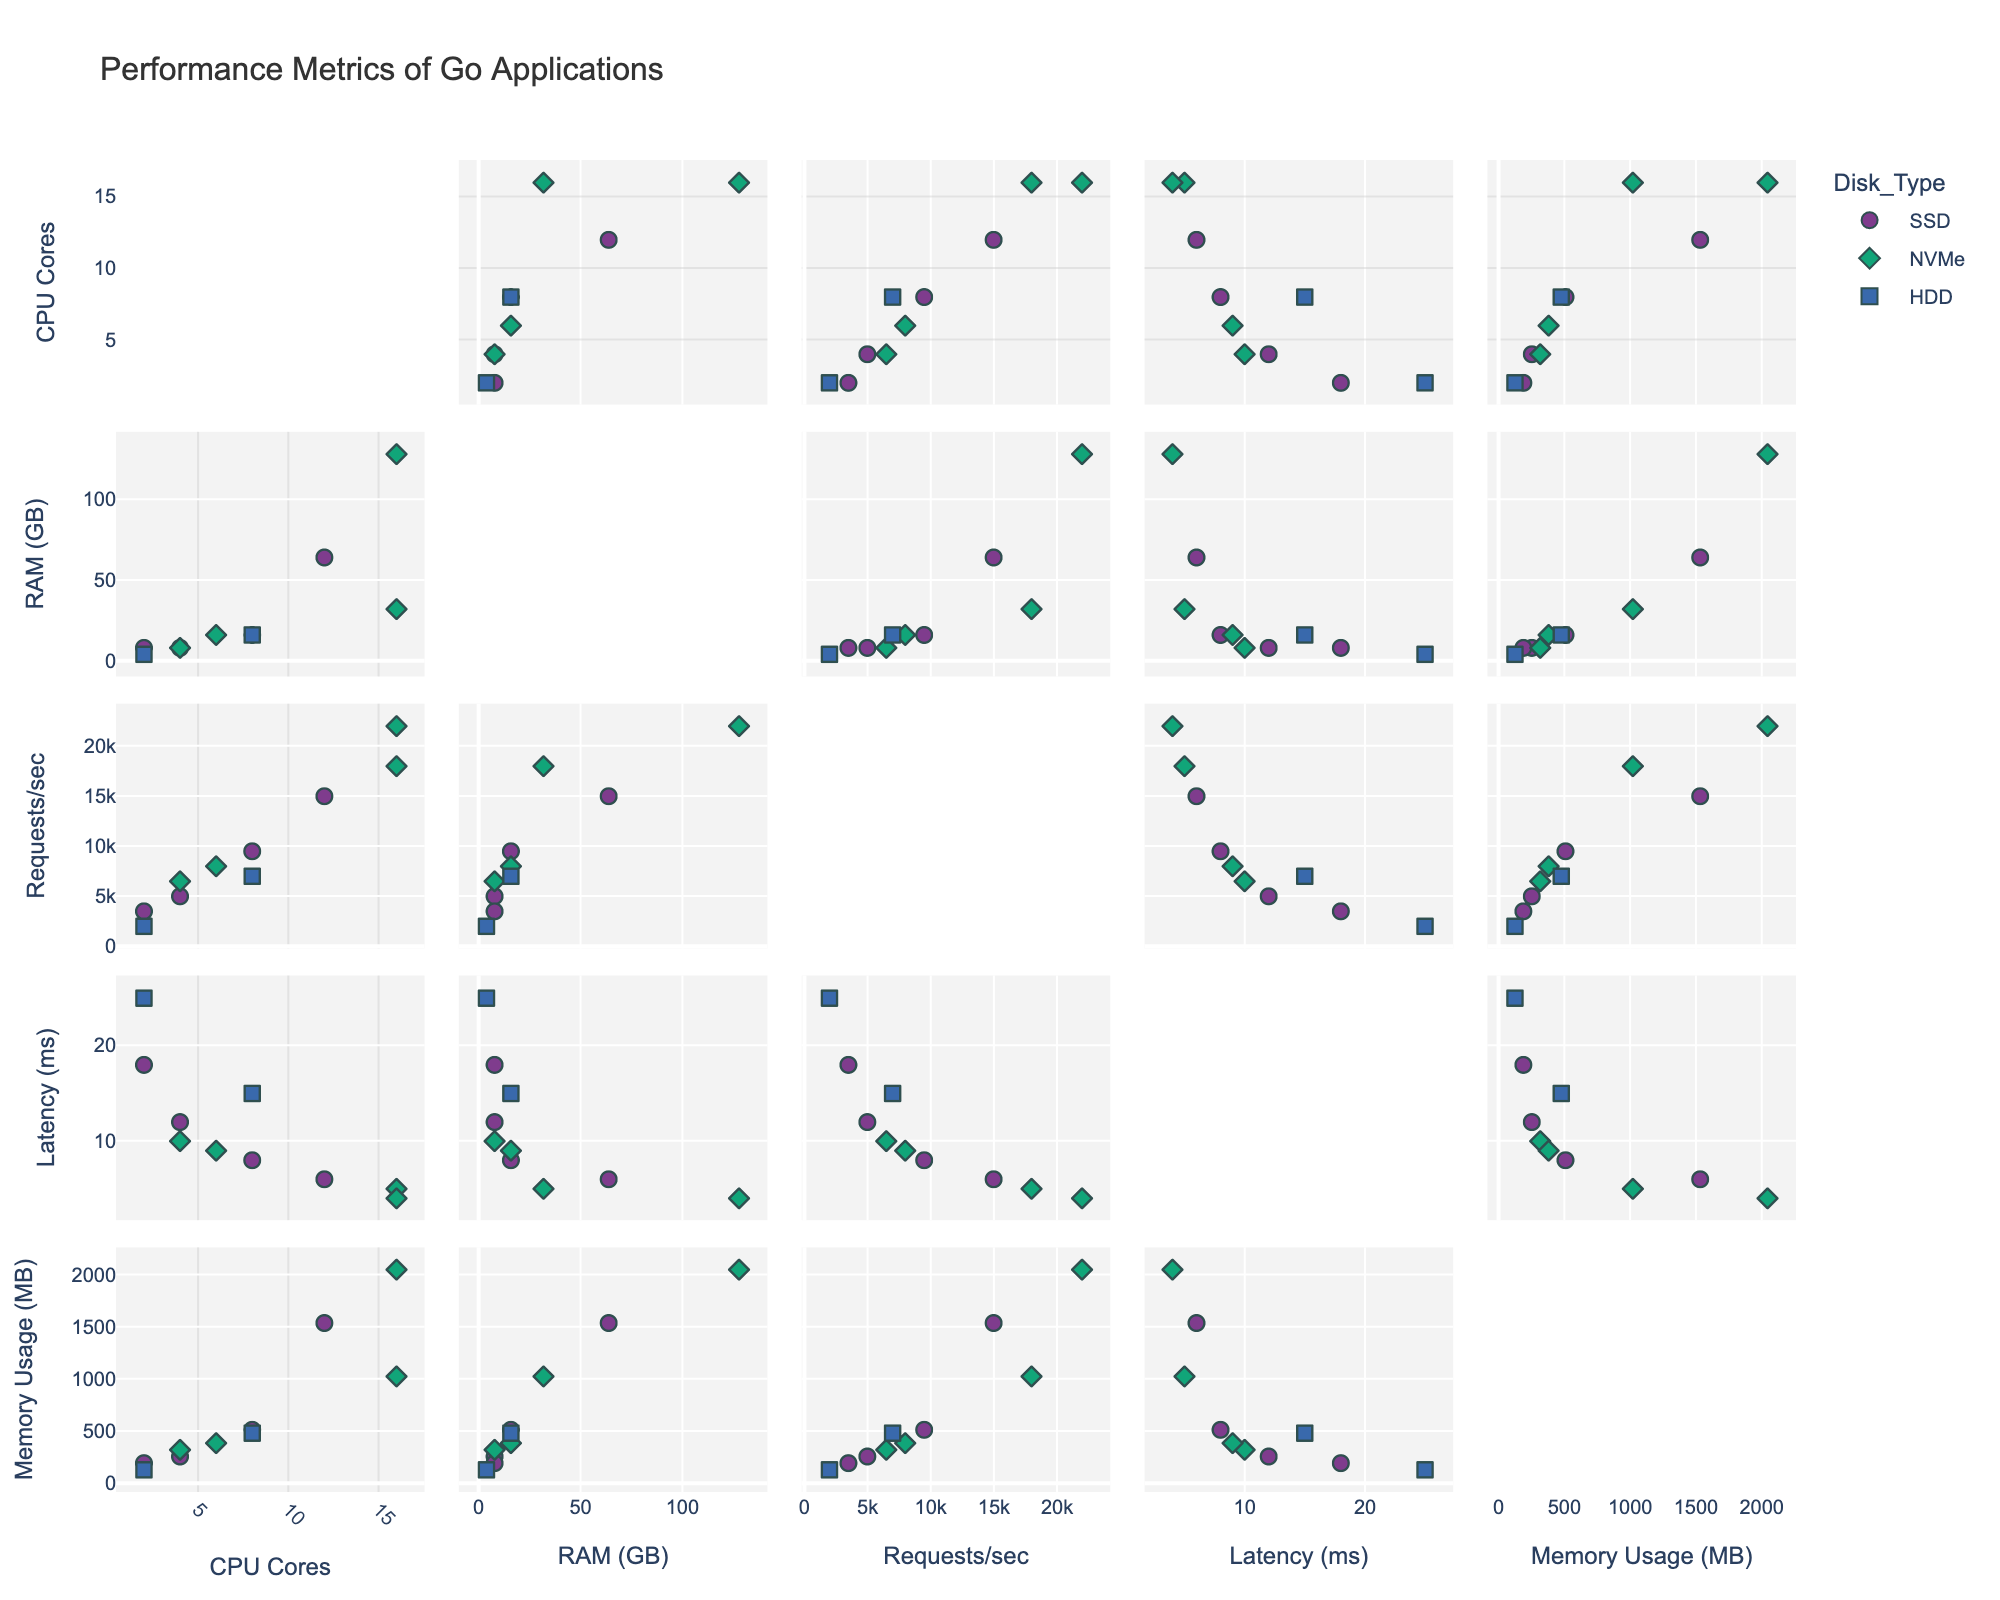What's the title of the figure? The title is usually displayed at the top of the chart. In this case, it reads 'Performance Metrics of Go Applications'.
Answer: Performance Metrics of Go Applications What are the units for Latency? The axis label for 'Latency' contains the unit, which is shown as 'Latency (ms)'.
Answer: ms How many data points are represented for configurations using SSD disk type? To determine this, we need to count the number of points colored for SSD in the scatterplot matrix. There are 4 data points for configurations using SSD.
Answer: 4 Which data point has the highest Requests per Second? Looking at the scatterplot matrix, locate the data point that has the highest value on the 'Requests per Second' axis. The highest value is 22000.
Answer: 22000 What is the relationship between RAM (GB) and Requests per Second for NVMe disk types? To determine this, look at the scatterplot comparing 'RAM (GB)' and 'Requests per Second' where the points are symbolized for NVMe. As RAM increases, Requests per Second tends to increase.
Answer: Positive correlation Which configuration has the lowest latency? To determine this, locate the data point with the smallest value on the 'Latency (ms)' axis. The lowest latency is 4 ms, which corresponds to the configuration with 16 CPU cores, 128 GB RAM, and NVMe disk type.
Answer: 16 CPU cores, 128 GB RAM, NVMe Between SSD and HDD, which disk type generally shows higher memory usage? To determine this, compare the memory usage distributions of data points for SSD and HDD. SSD generally shows higher memory usage as its data points are higher on the 'Memory Usage (MB)' axis.
Answer: SSD What is the most complex configuration that uses an HDD? To find this, look for the data point with the highest number of CPU cores and RAM among HDD disk types. The most complex configuration is 8 CPU cores and 16 GB RAM.
Answer: 8 CPU cores, 16 GB RAM How does disk type affect latency across different configurations? Analyze the scatterplots involving 'Latency (ms)' for different disk types. Generally, NVMe disk types show lower latency while HDD shows higher latency.
Answer: NVMe has lower latency Are there any configurations with 4 CPU Cores? What is their latency range? Locate data points with 4 CPU cores in the scatterplot. Their latency values range between 10 ms and 12 ms.
Answer: 10 ms to 12 ms 